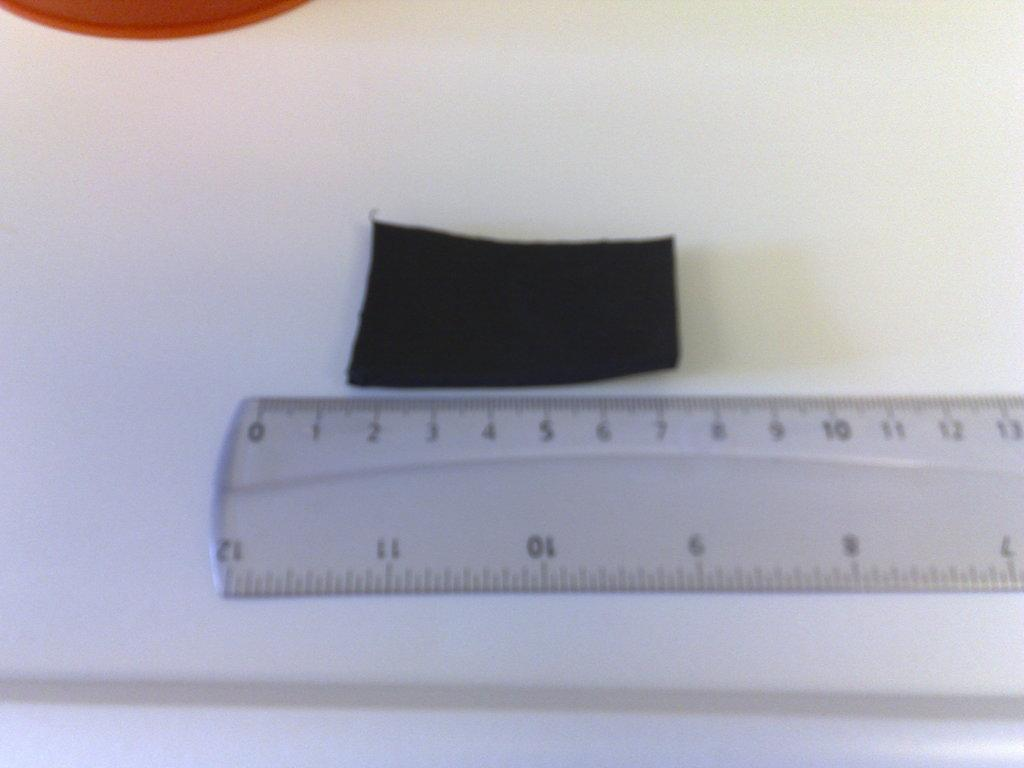What is the focus of the image? The image is zoomed in, with a ruler in the center. What is the ruler placed on? The ruler is placed on a white object, which appears to be a paper. Can you describe any items visible on the paper? Unfortunately, the provided facts do not give any information about the items placed on the paper. What type of beast can be seen interacting with the ruler in the image? There is no beast present in the image; it only features a ruler placed on a white object, which appears to be a paper. 